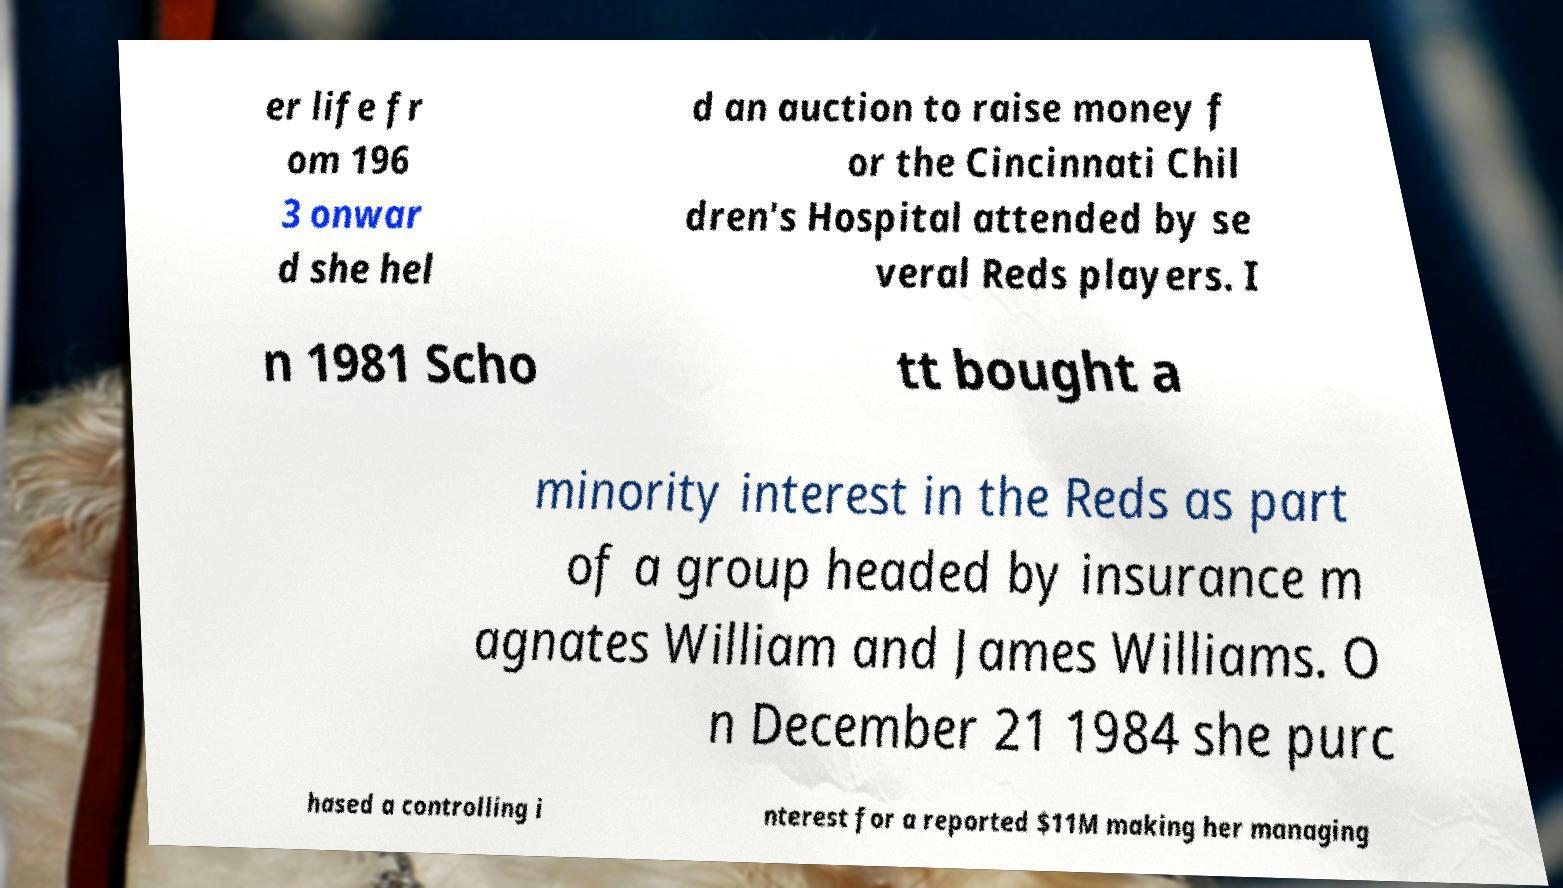For documentation purposes, I need the text within this image transcribed. Could you provide that? er life fr om 196 3 onwar d she hel d an auction to raise money f or the Cincinnati Chil dren's Hospital attended by se veral Reds players. I n 1981 Scho tt bought a minority interest in the Reds as part of a group headed by insurance m agnates William and James Williams. O n December 21 1984 she purc hased a controlling i nterest for a reported $11M making her managing 